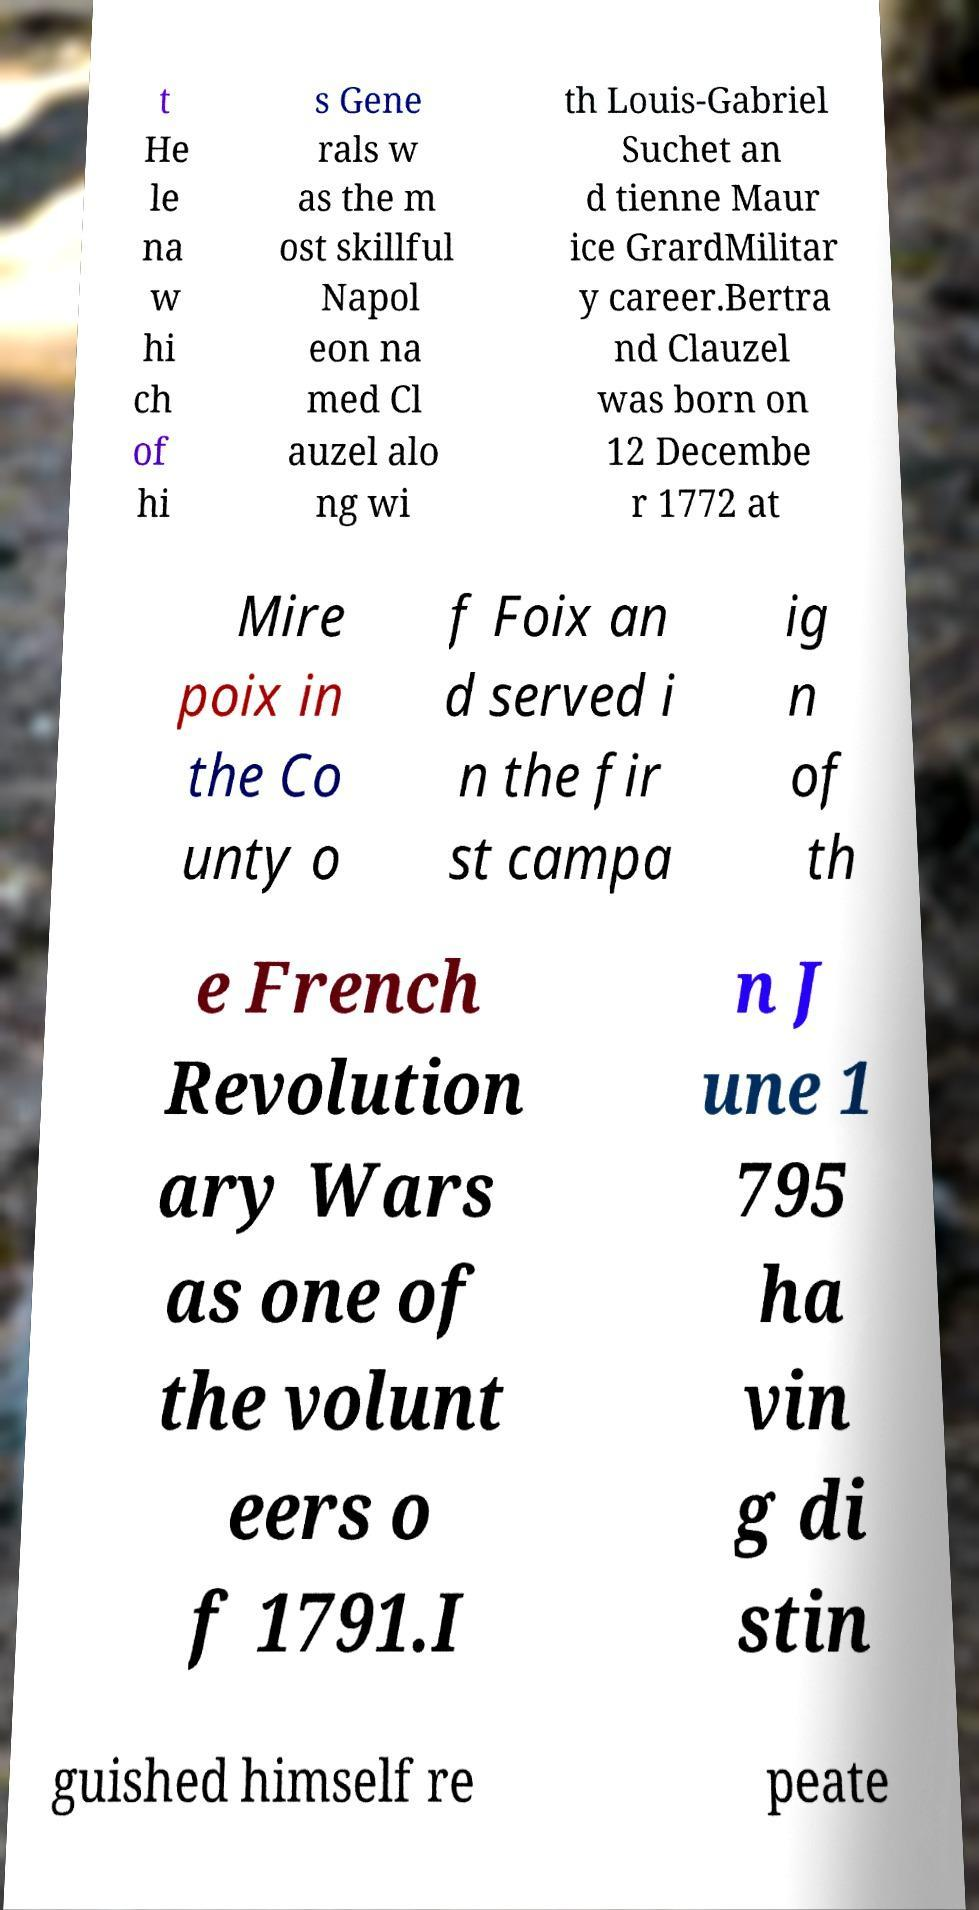For documentation purposes, I need the text within this image transcribed. Could you provide that? t He le na w hi ch of hi s Gene rals w as the m ost skillful Napol eon na med Cl auzel alo ng wi th Louis-Gabriel Suchet an d tienne Maur ice GrardMilitar y career.Bertra nd Clauzel was born on 12 Decembe r 1772 at Mire poix in the Co unty o f Foix an d served i n the fir st campa ig n of th e French Revolution ary Wars as one of the volunt eers o f 1791.I n J une 1 795 ha vin g di stin guished himself re peate 